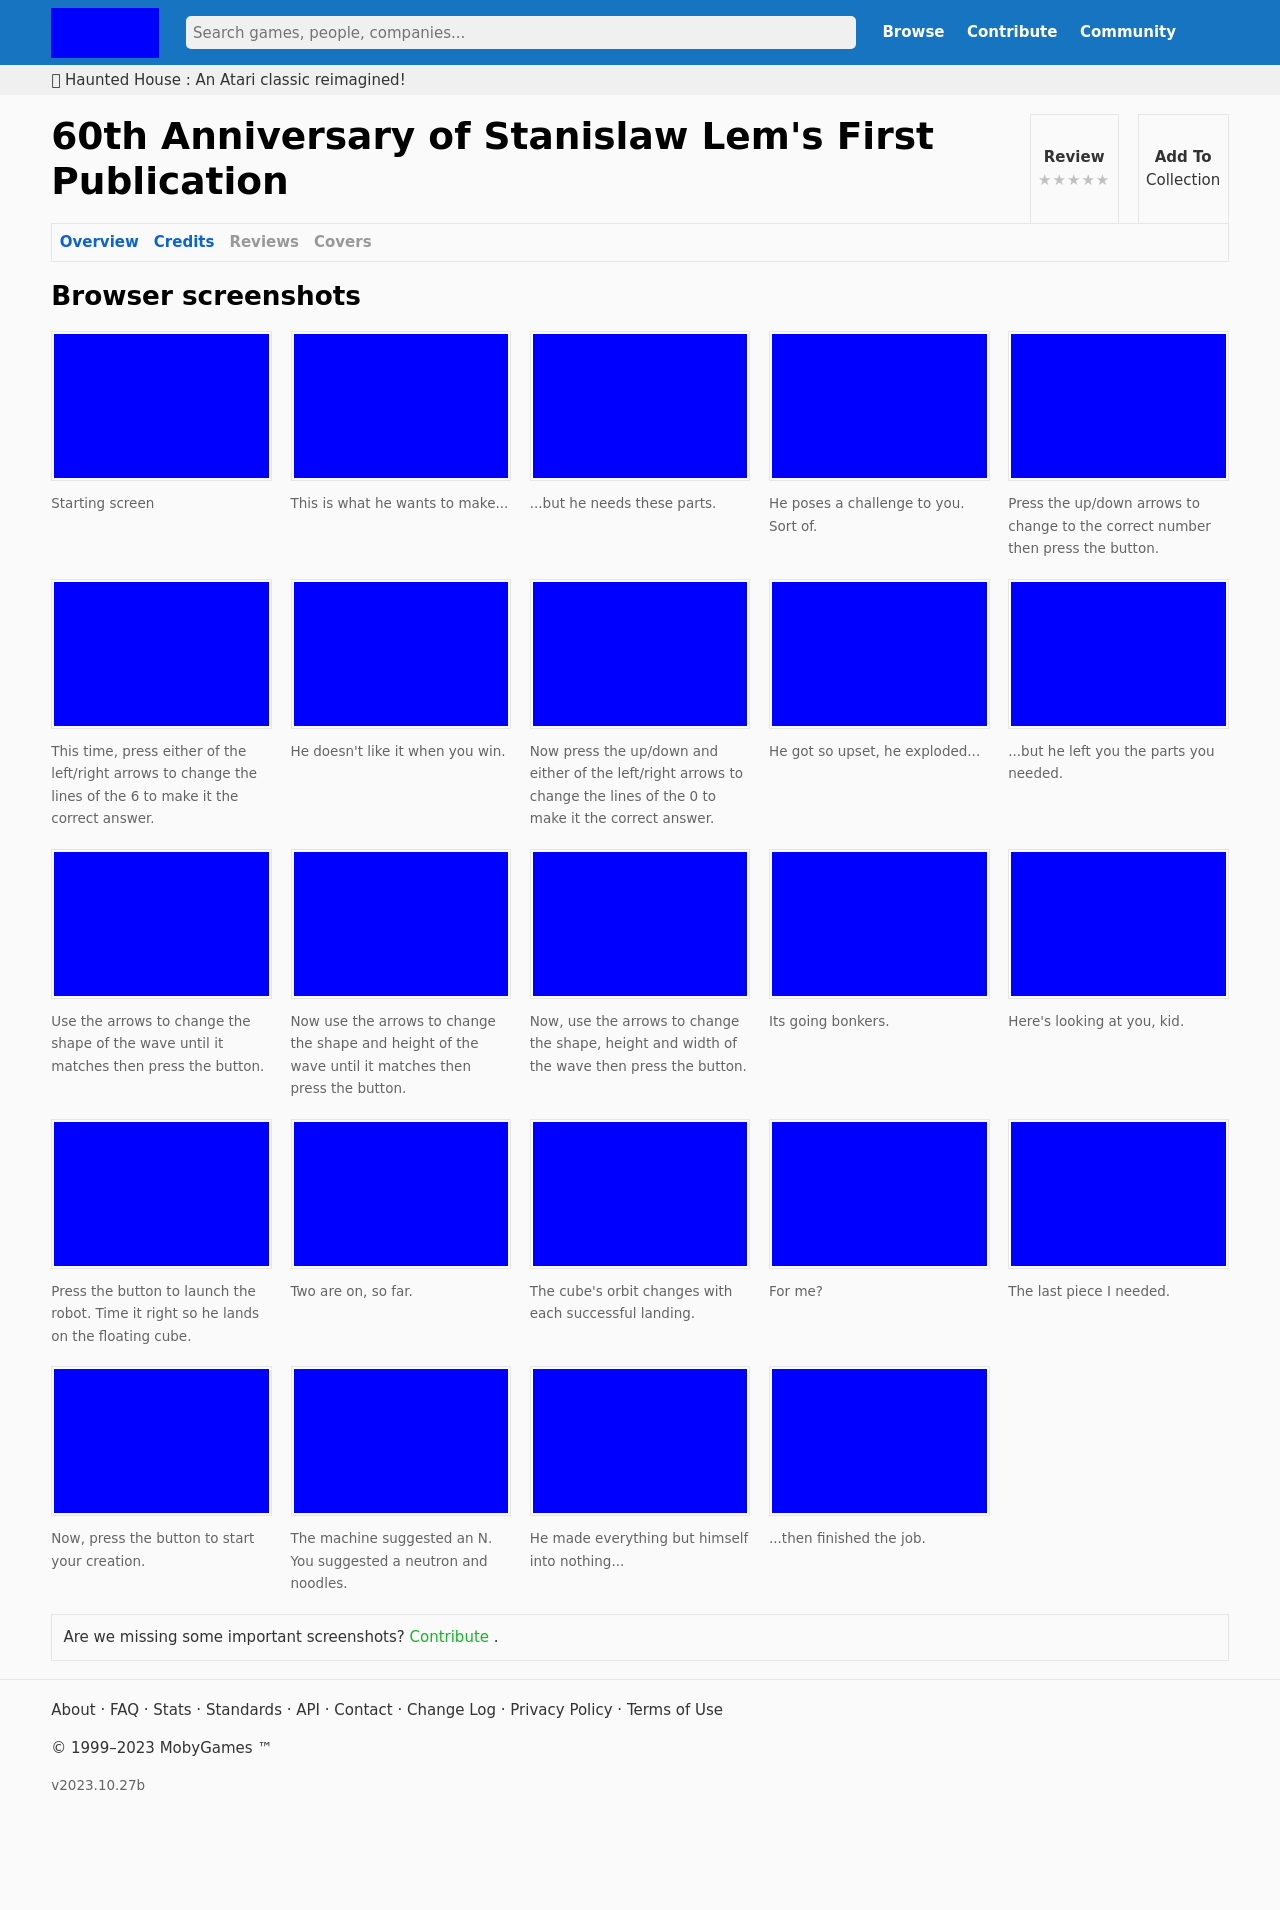Can you tell me more about the theme of the '60th Anniversary of Stanislaw Lem's First Publication' as shown in the screenshots? The '60th Anniversary of Stanislaw Lem's First Publication' appears to be a thematic tribute to Stanislaw Lem, a renowned science fiction writer. The screenshots hint at a game that involves problem-solving and exploration, likely reflecting Lem's narratives which often explored futuristic and philosophical themes. The game may have puzzles that challenge the player intellectually, mirroring the complex, thought-provoking nature of Lem's works. 